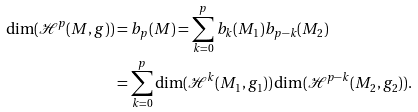<formula> <loc_0><loc_0><loc_500><loc_500>\dim ( \mathcal { H } ^ { p } ( M , g ) ) & = b _ { p } ( M ) = \sum _ { k = 0 } ^ { p } b _ { k } ( M _ { 1 } ) b _ { p - k } ( M _ { 2 } ) \\ & = \sum _ { k = 0 } ^ { p } \dim ( \mathcal { H } ^ { k } ( M _ { 1 } , g _ { 1 } ) ) \dim ( \mathcal { H } ^ { p - k } ( M _ { 2 } , g _ { 2 } ) ) .</formula> 